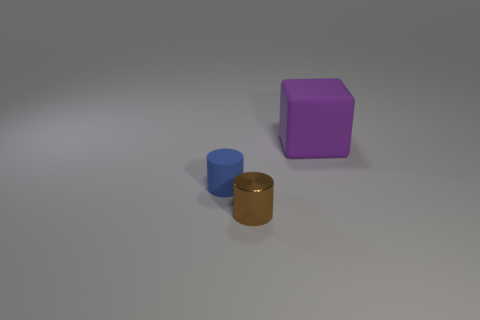There is a purple rubber cube that is on the right side of the tiny blue matte cylinder; is its size the same as the object left of the brown shiny object?
Provide a succinct answer. No. There is a purple object; does it have the same size as the cylinder that is in front of the blue rubber object?
Your answer should be compact. No. There is a thing that is on the left side of the small cylinder that is in front of the matte object that is in front of the big cube; what size is it?
Your response must be concise. Small. There is a matte thing to the left of the large rubber cube; does it have the same shape as the thing in front of the blue cylinder?
Give a very brief answer. Yes. Is the number of tiny blue things that are behind the small matte cylinder the same as the number of things?
Offer a very short reply. No. Is there a purple rubber object that is behind the rubber object on the left side of the purple thing?
Make the answer very short. Yes. Are there any other things that are the same color as the small matte cylinder?
Offer a terse response. No. Are the thing behind the small blue cylinder and the small blue cylinder made of the same material?
Provide a short and direct response. Yes. Are there an equal number of large rubber things that are left of the blue rubber cylinder and blue cylinders in front of the purple rubber object?
Offer a very short reply. No. What is the size of the cylinder that is to the right of the small cylinder left of the tiny brown cylinder?
Give a very brief answer. Small. 